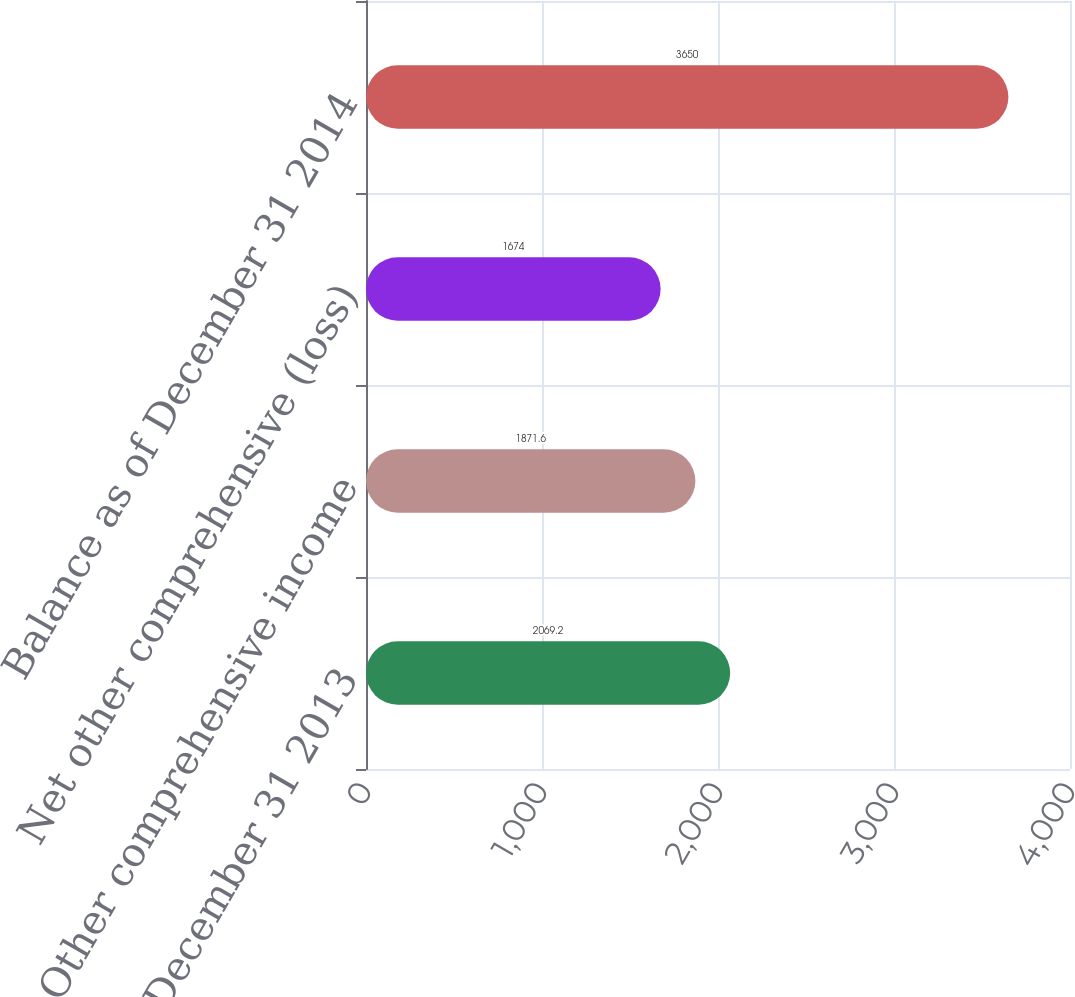Convert chart to OTSL. <chart><loc_0><loc_0><loc_500><loc_500><bar_chart><fcel>Balance as of December 31 2013<fcel>Other comprehensive income<fcel>Net other comprehensive (loss)<fcel>Balance as of December 31 2014<nl><fcel>2069.2<fcel>1871.6<fcel>1674<fcel>3650<nl></chart> 